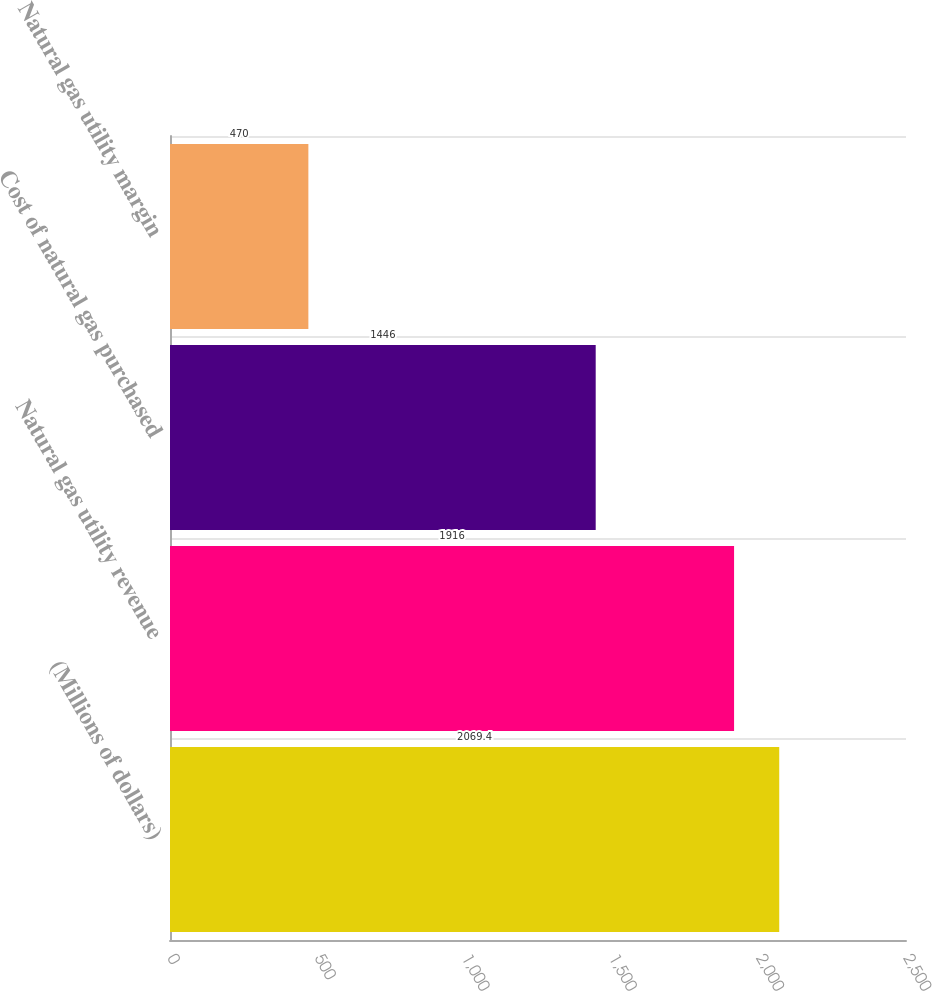<chart> <loc_0><loc_0><loc_500><loc_500><bar_chart><fcel>(Millions of dollars)<fcel>Natural gas utility revenue<fcel>Cost of natural gas purchased<fcel>Natural gas utility margin<nl><fcel>2069.4<fcel>1916<fcel>1446<fcel>470<nl></chart> 